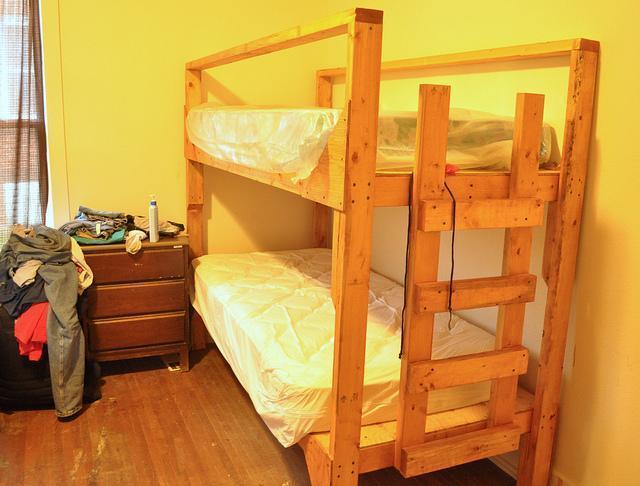How many suitcases are in the photo?
Give a very brief answer. 1. 